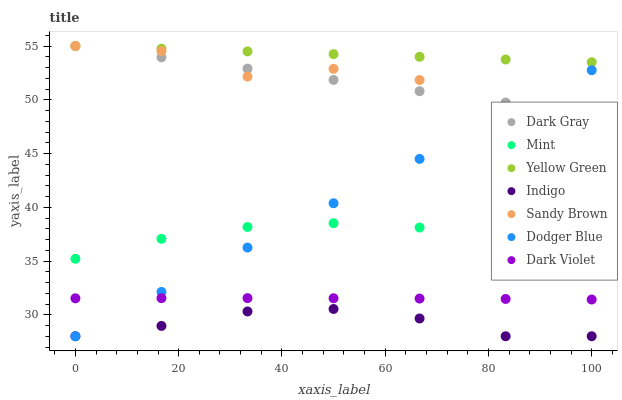Does Indigo have the minimum area under the curve?
Answer yes or no. Yes. Does Yellow Green have the maximum area under the curve?
Answer yes or no. Yes. Does Sandy Brown have the minimum area under the curve?
Answer yes or no. No. Does Sandy Brown have the maximum area under the curve?
Answer yes or no. No. Is Dark Gray the smoothest?
Answer yes or no. Yes. Is Sandy Brown the roughest?
Answer yes or no. Yes. Is Yellow Green the smoothest?
Answer yes or no. No. Is Yellow Green the roughest?
Answer yes or no. No. Does Indigo have the lowest value?
Answer yes or no. Yes. Does Sandy Brown have the lowest value?
Answer yes or no. No. Does Dark Gray have the highest value?
Answer yes or no. Yes. Does Dark Violet have the highest value?
Answer yes or no. No. Is Indigo less than Sandy Brown?
Answer yes or no. Yes. Is Yellow Green greater than Mint?
Answer yes or no. Yes. Does Dodger Blue intersect Dark Violet?
Answer yes or no. Yes. Is Dodger Blue less than Dark Violet?
Answer yes or no. No. Is Dodger Blue greater than Dark Violet?
Answer yes or no. No. Does Indigo intersect Sandy Brown?
Answer yes or no. No. 